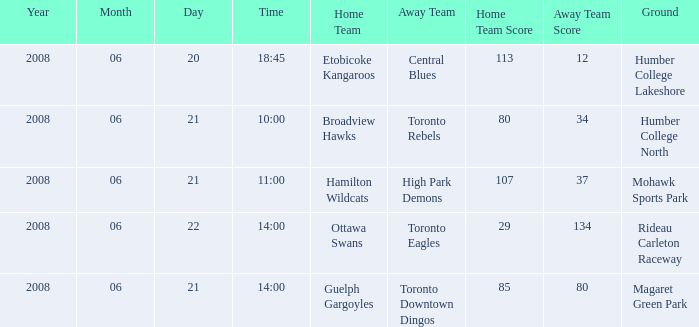What is the Time with a Ground that is humber college north? 10:00. Can you give me this table as a dict? {'header': ['Year', 'Month', 'Day', 'Time', 'Home Team', 'Away Team', 'Home Team Score', 'Away Team Score', 'Ground'], 'rows': [['2008', '06', '20', '18:45', 'Etobicoke Kangaroos', 'Central Blues', '113', '12', 'Humber College Lakeshore'], ['2008', '06', '21', '10:00', 'Broadview Hawks', 'Toronto Rebels', '80', '34', 'Humber College North'], ['2008', '06', '21', '11:00', 'Hamilton Wildcats', 'High Park Demons', '107', '37', 'Mohawk Sports Park'], ['2008', '06', '22', '14:00', 'Ottawa Swans', 'Toronto Eagles', '29', '134', 'Rideau Carleton Raceway'], ['2008', '06', '21', '14:00', 'Guelph Gargoyles', 'Toronto Downtown Dingos', '85', '80', 'Magaret Green Park']]} 